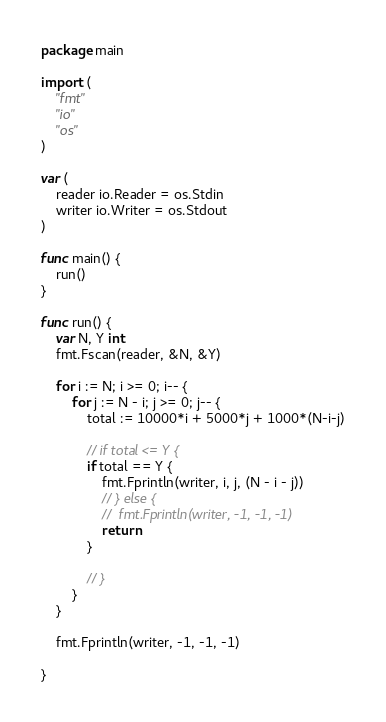Convert code to text. <code><loc_0><loc_0><loc_500><loc_500><_Go_>package main

import (
	"fmt"
	"io"
	"os"
)

var (
	reader io.Reader = os.Stdin
	writer io.Writer = os.Stdout
)

func main() {
	run()
}

func run() {
	var N, Y int
	fmt.Fscan(reader, &N, &Y)

	for i := N; i >= 0; i-- {
		for j := N - i; j >= 0; j-- {
			total := 10000*i + 5000*j + 1000*(N-i-j)

			// if total <= Y {
			if total == Y {
				fmt.Fprintln(writer, i, j, (N - i - j))
				// } else {
				// 	fmt.Fprintln(writer, -1, -1, -1)
				return
			}

			// }
		}
	}

	fmt.Fprintln(writer, -1, -1, -1)

}
</code> 